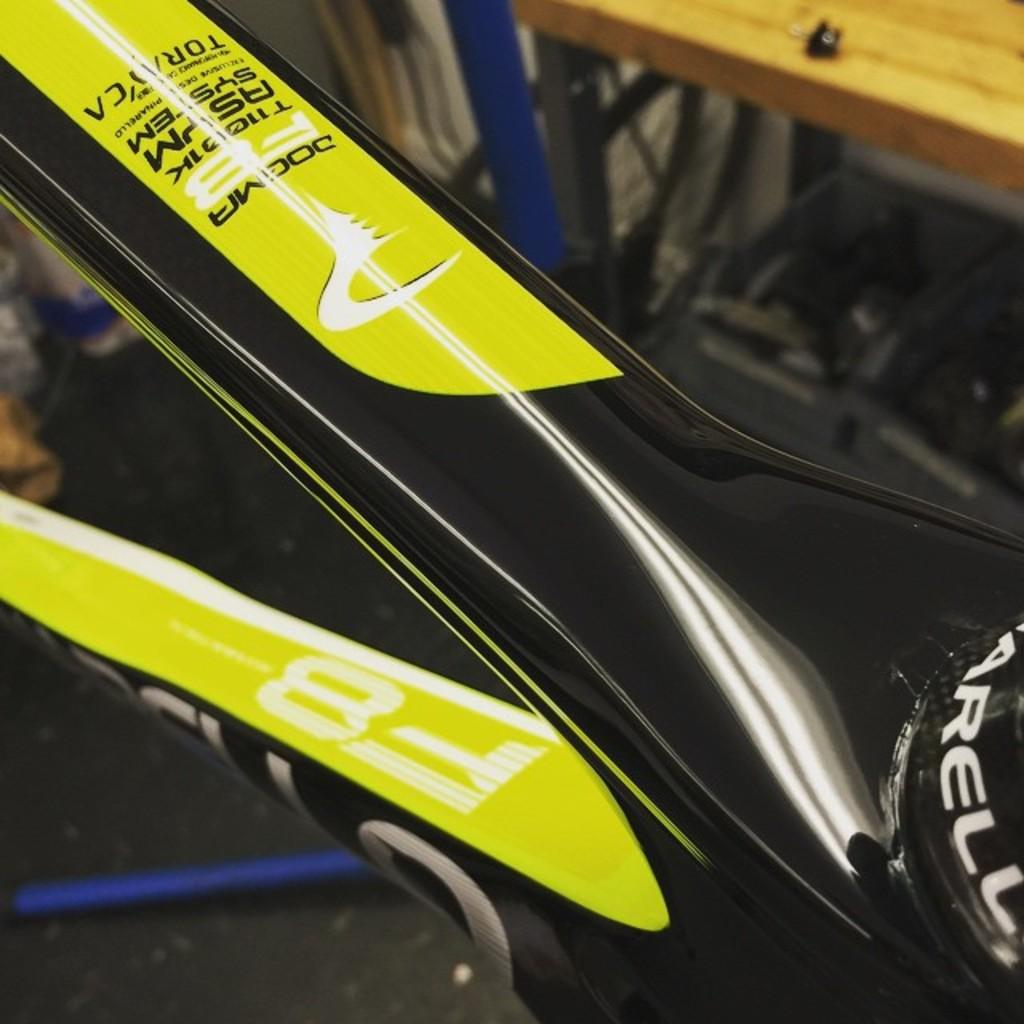What type of object is depicted in the image? The image contains rods of a bicycle. How is the bicycle positioned in the image? The bicycle is on the ground. What other object is present in the image? There is a bench in the image. How is the bench positioned in the image? The bench is also on the ground. Can you describe the background of the image? The background of the image is blurred. What type of fiction is the bicycle reading in the image? There is no indication in the image that the bicycle is reading any fiction, as bicycles are inanimate objects and cannot read. 